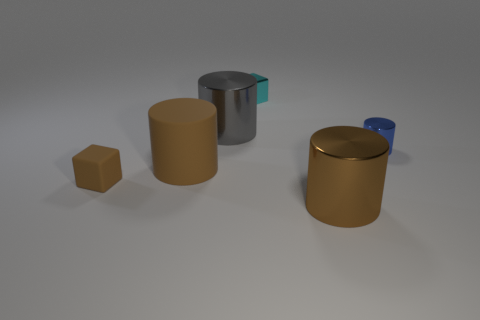Subtract all brown cylinders. How many were subtracted if there are1brown cylinders left? 1 Add 1 big gray cylinders. How many objects exist? 7 Subtract all cubes. How many objects are left? 4 Add 5 small metal cubes. How many small metal cubes exist? 6 Subtract 0 red spheres. How many objects are left? 6 Subtract all purple metallic things. Subtract all tiny brown rubber blocks. How many objects are left? 5 Add 6 matte cylinders. How many matte cylinders are left? 7 